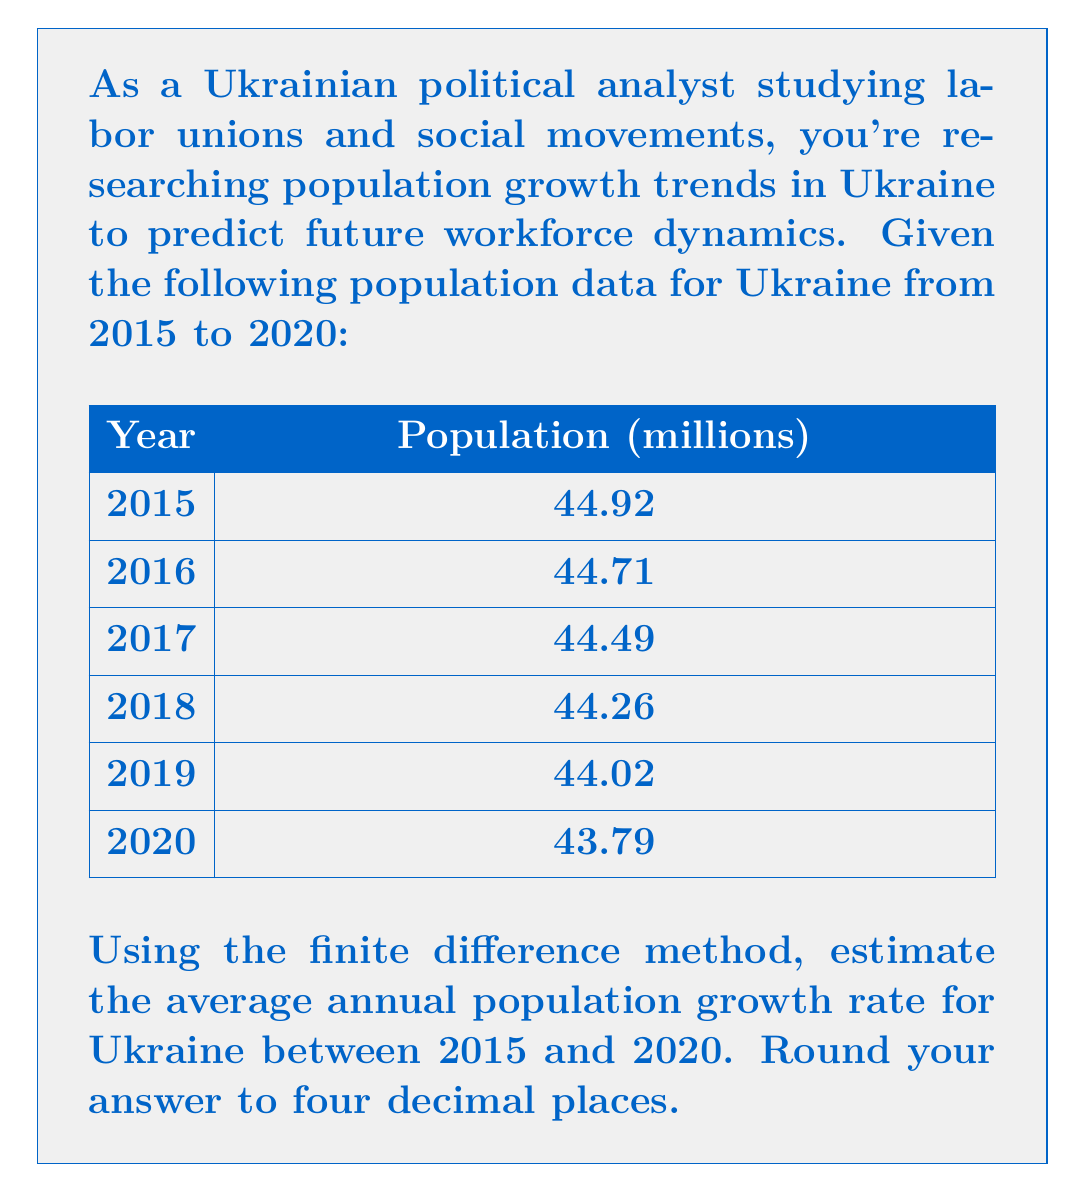Teach me how to tackle this problem. To estimate the average annual population growth rate using the finite difference method, we'll follow these steps:

1) The finite difference method for estimating growth rate uses the formula:

   $$r \approx \frac{1}{n} \sum_{i=1}^{n} \frac{P_{i} - P_{i-1}}{P_{i-1}}$$

   where $r$ is the average growth rate, $n$ is the number of intervals, and $P_i$ is the population at time $i$.

2) Calculate the growth rate for each year:

   2015 to 2016: $\frac{44.71 - 44.92}{44.92} = -0.00468$
   2016 to 2017: $\frac{44.49 - 44.71}{44.71} = -0.00492$
   2017 to 2018: $\frac{44.26 - 44.49}{44.49} = -0.00517$
   2018 to 2019: $\frac{44.02 - 44.26}{44.26} = -0.00542$
   2019 to 2020: $\frac{43.79 - 44.02}{44.02} = -0.00522$

3) Sum these rates:
   $-0.00468 + (-0.00492) + (-0.00517) + (-0.00542) + (-0.00522) = -0.02541$

4) Divide by the number of intervals (5) to get the average:
   $\frac{-0.02541}{5} = -0.005082$

5) Round to four decimal places: -0.0051

This negative growth rate indicates a declining population.
Answer: -0.0051 